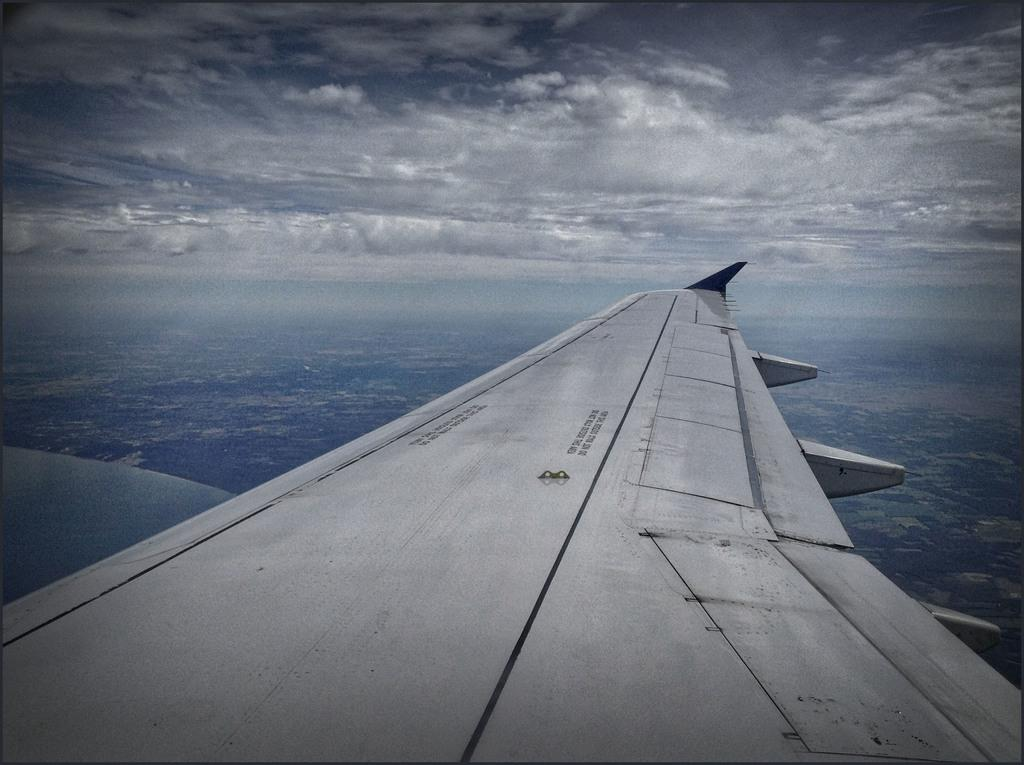What type of transportation is present in the image? There is an elevator in the image. What is visible at the top of the image? The sky is visible at the top of the image. Can you describe the sky in the image? The sky appears to be cloudy. Where is the queen wearing her mask in the image? There is no queen or mask present in the image. 